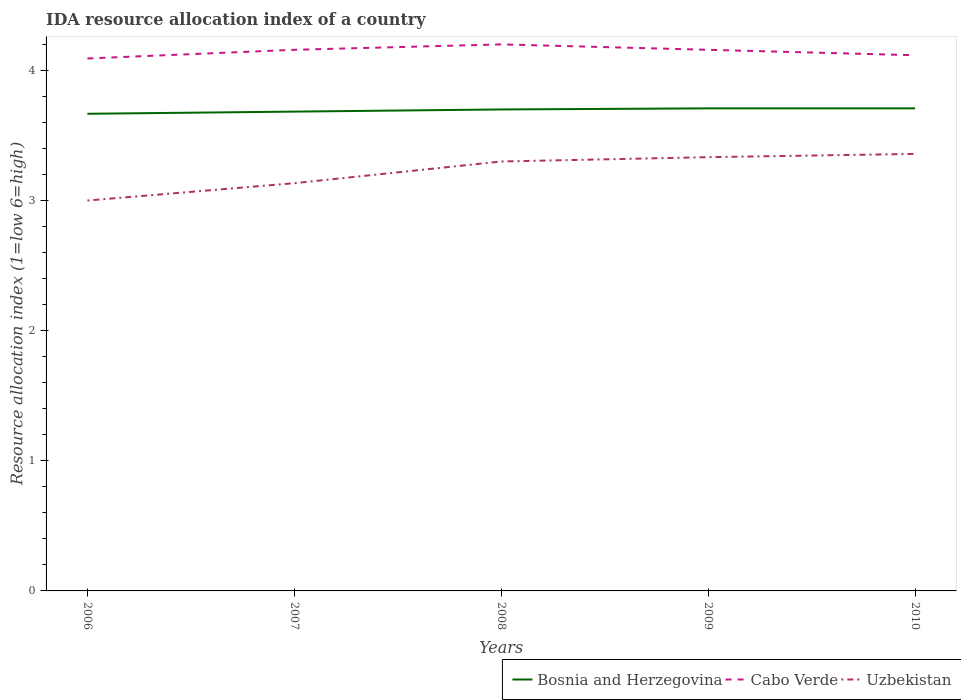What is the total IDA resource allocation index in Cabo Verde in the graph?
Keep it short and to the point. 0.08. What is the difference between the highest and the second highest IDA resource allocation index in Cabo Verde?
Keep it short and to the point. 0.11. How many lines are there?
Offer a terse response. 3. Does the graph contain any zero values?
Provide a short and direct response. No. Does the graph contain grids?
Keep it short and to the point. No. Where does the legend appear in the graph?
Your answer should be compact. Bottom right. How many legend labels are there?
Your answer should be very brief. 3. What is the title of the graph?
Offer a terse response. IDA resource allocation index of a country. What is the label or title of the X-axis?
Ensure brevity in your answer.  Years. What is the label or title of the Y-axis?
Provide a succinct answer. Resource allocation index (1=low 6=high). What is the Resource allocation index (1=low 6=high) in Bosnia and Herzegovina in 2006?
Keep it short and to the point. 3.67. What is the Resource allocation index (1=low 6=high) of Cabo Verde in 2006?
Provide a short and direct response. 4.09. What is the Resource allocation index (1=low 6=high) of Uzbekistan in 2006?
Keep it short and to the point. 3. What is the Resource allocation index (1=low 6=high) of Bosnia and Herzegovina in 2007?
Provide a short and direct response. 3.68. What is the Resource allocation index (1=low 6=high) in Cabo Verde in 2007?
Make the answer very short. 4.16. What is the Resource allocation index (1=low 6=high) of Uzbekistan in 2007?
Keep it short and to the point. 3.13. What is the Resource allocation index (1=low 6=high) in Bosnia and Herzegovina in 2008?
Offer a terse response. 3.7. What is the Resource allocation index (1=low 6=high) in Cabo Verde in 2008?
Your answer should be very brief. 4.2. What is the Resource allocation index (1=low 6=high) of Bosnia and Herzegovina in 2009?
Offer a very short reply. 3.71. What is the Resource allocation index (1=low 6=high) of Cabo Verde in 2009?
Keep it short and to the point. 4.16. What is the Resource allocation index (1=low 6=high) of Uzbekistan in 2009?
Your answer should be very brief. 3.33. What is the Resource allocation index (1=low 6=high) of Bosnia and Herzegovina in 2010?
Your answer should be compact. 3.71. What is the Resource allocation index (1=low 6=high) in Cabo Verde in 2010?
Ensure brevity in your answer.  4.12. What is the Resource allocation index (1=low 6=high) of Uzbekistan in 2010?
Your answer should be compact. 3.36. Across all years, what is the maximum Resource allocation index (1=low 6=high) in Bosnia and Herzegovina?
Ensure brevity in your answer.  3.71. Across all years, what is the maximum Resource allocation index (1=low 6=high) in Cabo Verde?
Your answer should be compact. 4.2. Across all years, what is the maximum Resource allocation index (1=low 6=high) in Uzbekistan?
Offer a terse response. 3.36. Across all years, what is the minimum Resource allocation index (1=low 6=high) of Bosnia and Herzegovina?
Provide a short and direct response. 3.67. Across all years, what is the minimum Resource allocation index (1=low 6=high) of Cabo Verde?
Offer a terse response. 4.09. Across all years, what is the minimum Resource allocation index (1=low 6=high) in Uzbekistan?
Your answer should be very brief. 3. What is the total Resource allocation index (1=low 6=high) of Bosnia and Herzegovina in the graph?
Keep it short and to the point. 18.47. What is the total Resource allocation index (1=low 6=high) of Cabo Verde in the graph?
Offer a very short reply. 20.73. What is the total Resource allocation index (1=low 6=high) of Uzbekistan in the graph?
Offer a very short reply. 16.12. What is the difference between the Resource allocation index (1=low 6=high) in Bosnia and Herzegovina in 2006 and that in 2007?
Your response must be concise. -0.02. What is the difference between the Resource allocation index (1=low 6=high) in Cabo Verde in 2006 and that in 2007?
Provide a short and direct response. -0.07. What is the difference between the Resource allocation index (1=low 6=high) in Uzbekistan in 2006 and that in 2007?
Ensure brevity in your answer.  -0.13. What is the difference between the Resource allocation index (1=low 6=high) of Bosnia and Herzegovina in 2006 and that in 2008?
Keep it short and to the point. -0.03. What is the difference between the Resource allocation index (1=low 6=high) in Cabo Verde in 2006 and that in 2008?
Provide a short and direct response. -0.11. What is the difference between the Resource allocation index (1=low 6=high) of Uzbekistan in 2006 and that in 2008?
Give a very brief answer. -0.3. What is the difference between the Resource allocation index (1=low 6=high) in Bosnia and Herzegovina in 2006 and that in 2009?
Provide a succinct answer. -0.04. What is the difference between the Resource allocation index (1=low 6=high) of Cabo Verde in 2006 and that in 2009?
Your answer should be compact. -0.07. What is the difference between the Resource allocation index (1=low 6=high) of Uzbekistan in 2006 and that in 2009?
Offer a terse response. -0.33. What is the difference between the Resource allocation index (1=low 6=high) in Bosnia and Herzegovina in 2006 and that in 2010?
Your answer should be compact. -0.04. What is the difference between the Resource allocation index (1=low 6=high) of Cabo Verde in 2006 and that in 2010?
Offer a very short reply. -0.03. What is the difference between the Resource allocation index (1=low 6=high) in Uzbekistan in 2006 and that in 2010?
Give a very brief answer. -0.36. What is the difference between the Resource allocation index (1=low 6=high) of Bosnia and Herzegovina in 2007 and that in 2008?
Offer a terse response. -0.02. What is the difference between the Resource allocation index (1=low 6=high) of Cabo Verde in 2007 and that in 2008?
Ensure brevity in your answer.  -0.04. What is the difference between the Resource allocation index (1=low 6=high) in Bosnia and Herzegovina in 2007 and that in 2009?
Give a very brief answer. -0.03. What is the difference between the Resource allocation index (1=low 6=high) in Cabo Verde in 2007 and that in 2009?
Your response must be concise. 0. What is the difference between the Resource allocation index (1=low 6=high) of Uzbekistan in 2007 and that in 2009?
Ensure brevity in your answer.  -0.2. What is the difference between the Resource allocation index (1=low 6=high) of Bosnia and Herzegovina in 2007 and that in 2010?
Offer a terse response. -0.03. What is the difference between the Resource allocation index (1=low 6=high) in Cabo Verde in 2007 and that in 2010?
Your answer should be very brief. 0.04. What is the difference between the Resource allocation index (1=low 6=high) in Uzbekistan in 2007 and that in 2010?
Provide a short and direct response. -0.23. What is the difference between the Resource allocation index (1=low 6=high) in Bosnia and Herzegovina in 2008 and that in 2009?
Your answer should be very brief. -0.01. What is the difference between the Resource allocation index (1=low 6=high) of Cabo Verde in 2008 and that in 2009?
Give a very brief answer. 0.04. What is the difference between the Resource allocation index (1=low 6=high) of Uzbekistan in 2008 and that in 2009?
Offer a terse response. -0.03. What is the difference between the Resource allocation index (1=low 6=high) in Bosnia and Herzegovina in 2008 and that in 2010?
Your response must be concise. -0.01. What is the difference between the Resource allocation index (1=low 6=high) of Cabo Verde in 2008 and that in 2010?
Provide a short and direct response. 0.08. What is the difference between the Resource allocation index (1=low 6=high) of Uzbekistan in 2008 and that in 2010?
Offer a very short reply. -0.06. What is the difference between the Resource allocation index (1=low 6=high) in Cabo Verde in 2009 and that in 2010?
Make the answer very short. 0.04. What is the difference between the Resource allocation index (1=low 6=high) in Uzbekistan in 2009 and that in 2010?
Your response must be concise. -0.03. What is the difference between the Resource allocation index (1=low 6=high) of Bosnia and Herzegovina in 2006 and the Resource allocation index (1=low 6=high) of Cabo Verde in 2007?
Offer a very short reply. -0.49. What is the difference between the Resource allocation index (1=low 6=high) in Bosnia and Herzegovina in 2006 and the Resource allocation index (1=low 6=high) in Uzbekistan in 2007?
Provide a short and direct response. 0.53. What is the difference between the Resource allocation index (1=low 6=high) of Cabo Verde in 2006 and the Resource allocation index (1=low 6=high) of Uzbekistan in 2007?
Provide a short and direct response. 0.96. What is the difference between the Resource allocation index (1=low 6=high) in Bosnia and Herzegovina in 2006 and the Resource allocation index (1=low 6=high) in Cabo Verde in 2008?
Your answer should be very brief. -0.53. What is the difference between the Resource allocation index (1=low 6=high) of Bosnia and Herzegovina in 2006 and the Resource allocation index (1=low 6=high) of Uzbekistan in 2008?
Offer a very short reply. 0.37. What is the difference between the Resource allocation index (1=low 6=high) of Cabo Verde in 2006 and the Resource allocation index (1=low 6=high) of Uzbekistan in 2008?
Your answer should be very brief. 0.79. What is the difference between the Resource allocation index (1=low 6=high) of Bosnia and Herzegovina in 2006 and the Resource allocation index (1=low 6=high) of Cabo Verde in 2009?
Your response must be concise. -0.49. What is the difference between the Resource allocation index (1=low 6=high) of Cabo Verde in 2006 and the Resource allocation index (1=low 6=high) of Uzbekistan in 2009?
Ensure brevity in your answer.  0.76. What is the difference between the Resource allocation index (1=low 6=high) in Bosnia and Herzegovina in 2006 and the Resource allocation index (1=low 6=high) in Cabo Verde in 2010?
Offer a terse response. -0.45. What is the difference between the Resource allocation index (1=low 6=high) in Bosnia and Herzegovina in 2006 and the Resource allocation index (1=low 6=high) in Uzbekistan in 2010?
Ensure brevity in your answer.  0.31. What is the difference between the Resource allocation index (1=low 6=high) of Cabo Verde in 2006 and the Resource allocation index (1=low 6=high) of Uzbekistan in 2010?
Your answer should be very brief. 0.73. What is the difference between the Resource allocation index (1=low 6=high) of Bosnia and Herzegovina in 2007 and the Resource allocation index (1=low 6=high) of Cabo Verde in 2008?
Offer a terse response. -0.52. What is the difference between the Resource allocation index (1=low 6=high) in Bosnia and Herzegovina in 2007 and the Resource allocation index (1=low 6=high) in Uzbekistan in 2008?
Offer a terse response. 0.38. What is the difference between the Resource allocation index (1=low 6=high) in Cabo Verde in 2007 and the Resource allocation index (1=low 6=high) in Uzbekistan in 2008?
Your answer should be very brief. 0.86. What is the difference between the Resource allocation index (1=low 6=high) in Bosnia and Herzegovina in 2007 and the Resource allocation index (1=low 6=high) in Cabo Verde in 2009?
Make the answer very short. -0.47. What is the difference between the Resource allocation index (1=low 6=high) of Bosnia and Herzegovina in 2007 and the Resource allocation index (1=low 6=high) of Uzbekistan in 2009?
Your answer should be compact. 0.35. What is the difference between the Resource allocation index (1=low 6=high) in Cabo Verde in 2007 and the Resource allocation index (1=low 6=high) in Uzbekistan in 2009?
Your answer should be compact. 0.82. What is the difference between the Resource allocation index (1=low 6=high) in Bosnia and Herzegovina in 2007 and the Resource allocation index (1=low 6=high) in Cabo Verde in 2010?
Keep it short and to the point. -0.43. What is the difference between the Resource allocation index (1=low 6=high) of Bosnia and Herzegovina in 2007 and the Resource allocation index (1=low 6=high) of Uzbekistan in 2010?
Your answer should be compact. 0.33. What is the difference between the Resource allocation index (1=low 6=high) in Bosnia and Herzegovina in 2008 and the Resource allocation index (1=low 6=high) in Cabo Verde in 2009?
Provide a short and direct response. -0.46. What is the difference between the Resource allocation index (1=low 6=high) in Bosnia and Herzegovina in 2008 and the Resource allocation index (1=low 6=high) in Uzbekistan in 2009?
Keep it short and to the point. 0.37. What is the difference between the Resource allocation index (1=low 6=high) in Cabo Verde in 2008 and the Resource allocation index (1=low 6=high) in Uzbekistan in 2009?
Give a very brief answer. 0.87. What is the difference between the Resource allocation index (1=low 6=high) of Bosnia and Herzegovina in 2008 and the Resource allocation index (1=low 6=high) of Cabo Verde in 2010?
Provide a succinct answer. -0.42. What is the difference between the Resource allocation index (1=low 6=high) in Bosnia and Herzegovina in 2008 and the Resource allocation index (1=low 6=high) in Uzbekistan in 2010?
Keep it short and to the point. 0.34. What is the difference between the Resource allocation index (1=low 6=high) in Cabo Verde in 2008 and the Resource allocation index (1=low 6=high) in Uzbekistan in 2010?
Give a very brief answer. 0.84. What is the difference between the Resource allocation index (1=low 6=high) of Bosnia and Herzegovina in 2009 and the Resource allocation index (1=low 6=high) of Cabo Verde in 2010?
Keep it short and to the point. -0.41. What is the difference between the Resource allocation index (1=low 6=high) in Bosnia and Herzegovina in 2009 and the Resource allocation index (1=low 6=high) in Uzbekistan in 2010?
Provide a short and direct response. 0.35. What is the difference between the Resource allocation index (1=low 6=high) in Cabo Verde in 2009 and the Resource allocation index (1=low 6=high) in Uzbekistan in 2010?
Make the answer very short. 0.8. What is the average Resource allocation index (1=low 6=high) of Bosnia and Herzegovina per year?
Offer a very short reply. 3.69. What is the average Resource allocation index (1=low 6=high) of Cabo Verde per year?
Your answer should be very brief. 4.14. What is the average Resource allocation index (1=low 6=high) in Uzbekistan per year?
Make the answer very short. 3.23. In the year 2006, what is the difference between the Resource allocation index (1=low 6=high) in Bosnia and Herzegovina and Resource allocation index (1=low 6=high) in Cabo Verde?
Make the answer very short. -0.42. In the year 2006, what is the difference between the Resource allocation index (1=low 6=high) of Bosnia and Herzegovina and Resource allocation index (1=low 6=high) of Uzbekistan?
Your answer should be compact. 0.67. In the year 2006, what is the difference between the Resource allocation index (1=low 6=high) in Cabo Verde and Resource allocation index (1=low 6=high) in Uzbekistan?
Offer a very short reply. 1.09. In the year 2007, what is the difference between the Resource allocation index (1=low 6=high) of Bosnia and Herzegovina and Resource allocation index (1=low 6=high) of Cabo Verde?
Give a very brief answer. -0.47. In the year 2007, what is the difference between the Resource allocation index (1=low 6=high) of Bosnia and Herzegovina and Resource allocation index (1=low 6=high) of Uzbekistan?
Offer a terse response. 0.55. In the year 2008, what is the difference between the Resource allocation index (1=low 6=high) of Bosnia and Herzegovina and Resource allocation index (1=low 6=high) of Uzbekistan?
Provide a short and direct response. 0.4. In the year 2008, what is the difference between the Resource allocation index (1=low 6=high) of Cabo Verde and Resource allocation index (1=low 6=high) of Uzbekistan?
Make the answer very short. 0.9. In the year 2009, what is the difference between the Resource allocation index (1=low 6=high) of Bosnia and Herzegovina and Resource allocation index (1=low 6=high) of Cabo Verde?
Provide a short and direct response. -0.45. In the year 2009, what is the difference between the Resource allocation index (1=low 6=high) of Cabo Verde and Resource allocation index (1=low 6=high) of Uzbekistan?
Provide a succinct answer. 0.82. In the year 2010, what is the difference between the Resource allocation index (1=low 6=high) of Bosnia and Herzegovina and Resource allocation index (1=low 6=high) of Cabo Verde?
Offer a terse response. -0.41. In the year 2010, what is the difference between the Resource allocation index (1=low 6=high) of Cabo Verde and Resource allocation index (1=low 6=high) of Uzbekistan?
Offer a very short reply. 0.76. What is the ratio of the Resource allocation index (1=low 6=high) in Uzbekistan in 2006 to that in 2007?
Keep it short and to the point. 0.96. What is the ratio of the Resource allocation index (1=low 6=high) of Bosnia and Herzegovina in 2006 to that in 2008?
Keep it short and to the point. 0.99. What is the ratio of the Resource allocation index (1=low 6=high) of Cabo Verde in 2006 to that in 2008?
Your answer should be compact. 0.97. What is the ratio of the Resource allocation index (1=low 6=high) in Uzbekistan in 2006 to that in 2008?
Ensure brevity in your answer.  0.91. What is the ratio of the Resource allocation index (1=low 6=high) of Bosnia and Herzegovina in 2006 to that in 2009?
Your response must be concise. 0.99. What is the ratio of the Resource allocation index (1=low 6=high) in Cabo Verde in 2006 to that in 2010?
Provide a succinct answer. 0.99. What is the ratio of the Resource allocation index (1=low 6=high) in Uzbekistan in 2006 to that in 2010?
Keep it short and to the point. 0.89. What is the ratio of the Resource allocation index (1=low 6=high) of Cabo Verde in 2007 to that in 2008?
Your answer should be compact. 0.99. What is the ratio of the Resource allocation index (1=low 6=high) in Uzbekistan in 2007 to that in 2008?
Offer a terse response. 0.95. What is the ratio of the Resource allocation index (1=low 6=high) in Bosnia and Herzegovina in 2007 to that in 2009?
Your response must be concise. 0.99. What is the ratio of the Resource allocation index (1=low 6=high) of Cabo Verde in 2007 to that in 2009?
Keep it short and to the point. 1. What is the ratio of the Resource allocation index (1=low 6=high) in Bosnia and Herzegovina in 2007 to that in 2010?
Your answer should be compact. 0.99. What is the ratio of the Resource allocation index (1=low 6=high) in Cabo Verde in 2007 to that in 2010?
Your answer should be compact. 1.01. What is the ratio of the Resource allocation index (1=low 6=high) in Uzbekistan in 2007 to that in 2010?
Your answer should be very brief. 0.93. What is the ratio of the Resource allocation index (1=low 6=high) of Cabo Verde in 2008 to that in 2010?
Provide a succinct answer. 1.02. What is the ratio of the Resource allocation index (1=low 6=high) of Uzbekistan in 2008 to that in 2010?
Offer a very short reply. 0.98. What is the ratio of the Resource allocation index (1=low 6=high) of Cabo Verde in 2009 to that in 2010?
Your answer should be very brief. 1.01. What is the difference between the highest and the second highest Resource allocation index (1=low 6=high) of Cabo Verde?
Provide a succinct answer. 0.04. What is the difference between the highest and the second highest Resource allocation index (1=low 6=high) in Uzbekistan?
Your response must be concise. 0.03. What is the difference between the highest and the lowest Resource allocation index (1=low 6=high) of Bosnia and Herzegovina?
Provide a short and direct response. 0.04. What is the difference between the highest and the lowest Resource allocation index (1=low 6=high) in Cabo Verde?
Make the answer very short. 0.11. What is the difference between the highest and the lowest Resource allocation index (1=low 6=high) in Uzbekistan?
Provide a succinct answer. 0.36. 